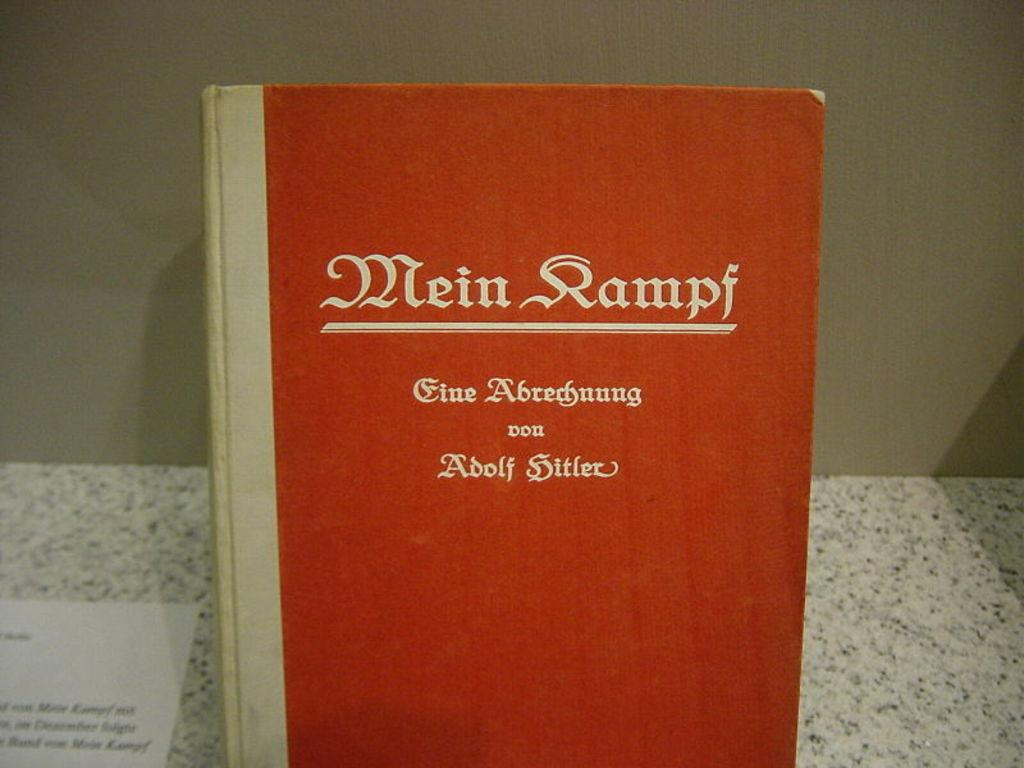<image>
Give a short and clear explanation of the subsequent image. a close up of the book Mein Kampf with other german text 